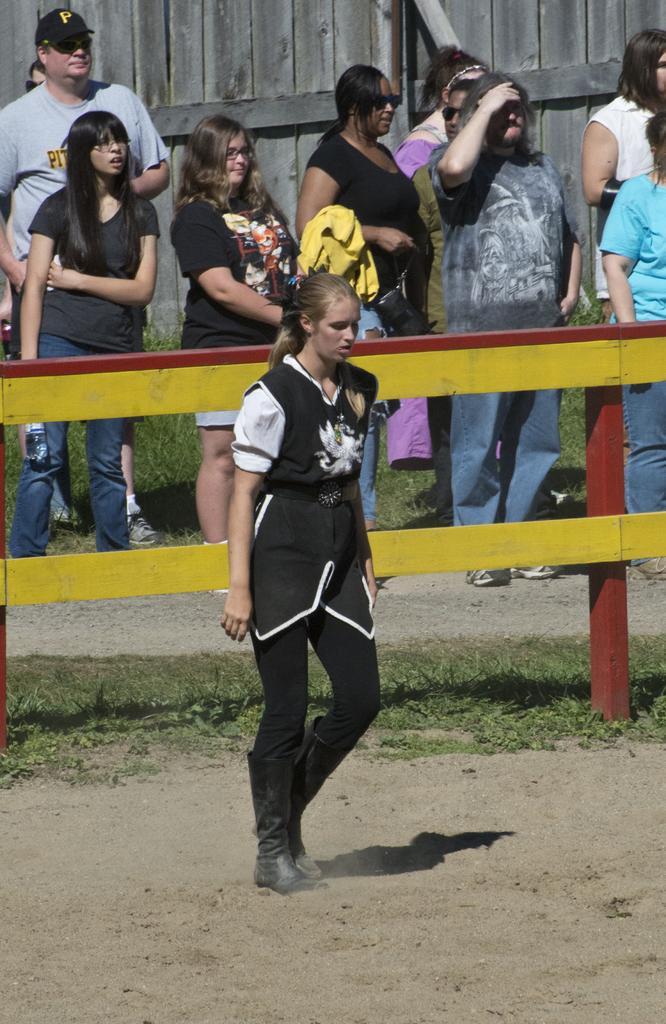How would you summarize this image in a sentence or two? In the picture we can see a woman walking on the ground surface and behind her we can see a railing which is yellow in color and behind it, we can see a path with many people are standing and behind them we can see the wooden wall. 